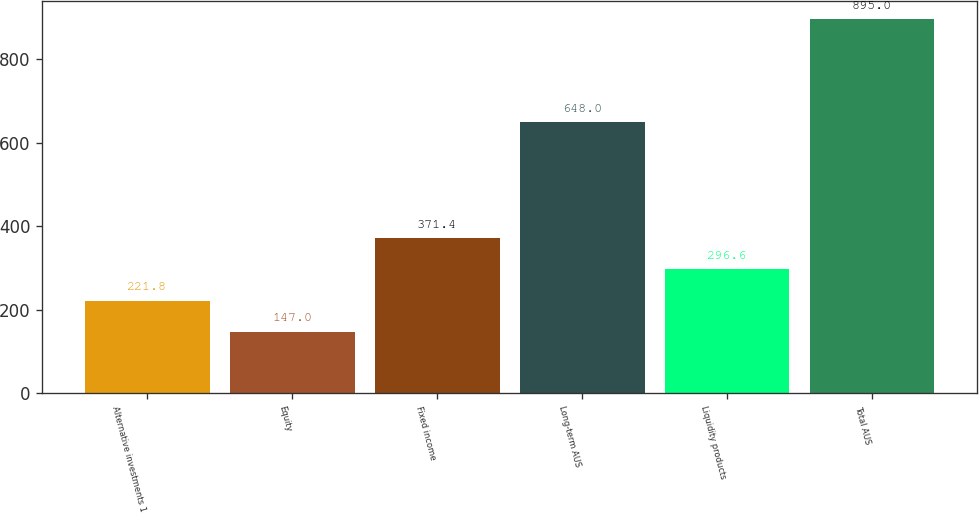<chart> <loc_0><loc_0><loc_500><loc_500><bar_chart><fcel>Alternative investments 1<fcel>Equity<fcel>Fixed income<fcel>Long-term AUS<fcel>Liquidity products<fcel>Total AUS<nl><fcel>221.8<fcel>147<fcel>371.4<fcel>648<fcel>296.6<fcel>895<nl></chart> 